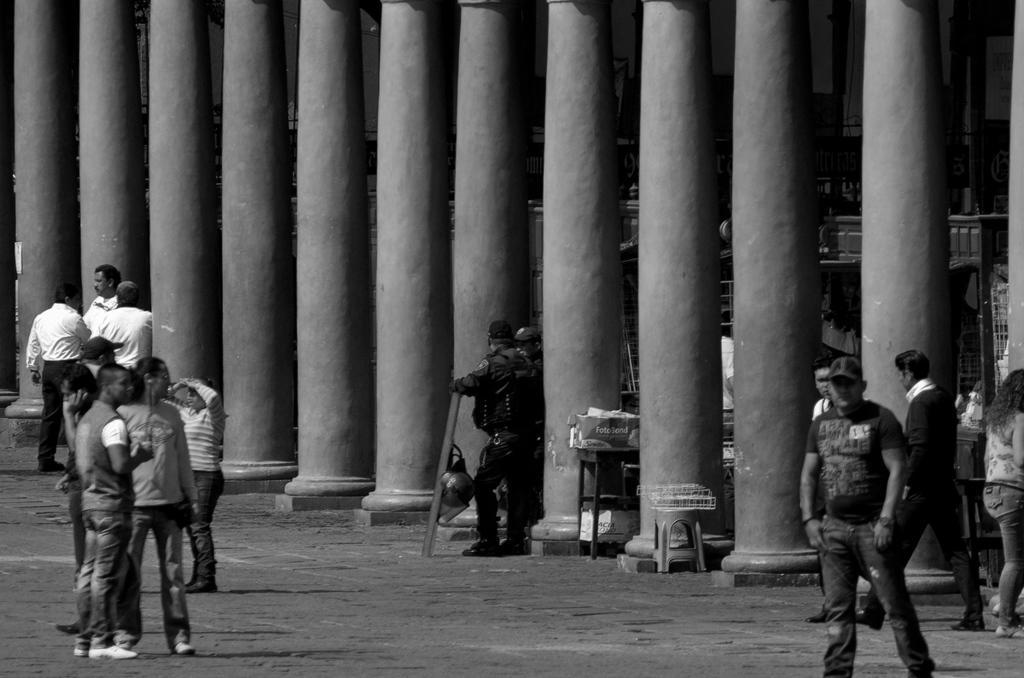How would you summarize this image in a sentence or two? In this image I can see some people. In the background, I can see the pillars. 